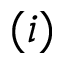Convert formula to latex. <formula><loc_0><loc_0><loc_500><loc_500>( i )</formula> 